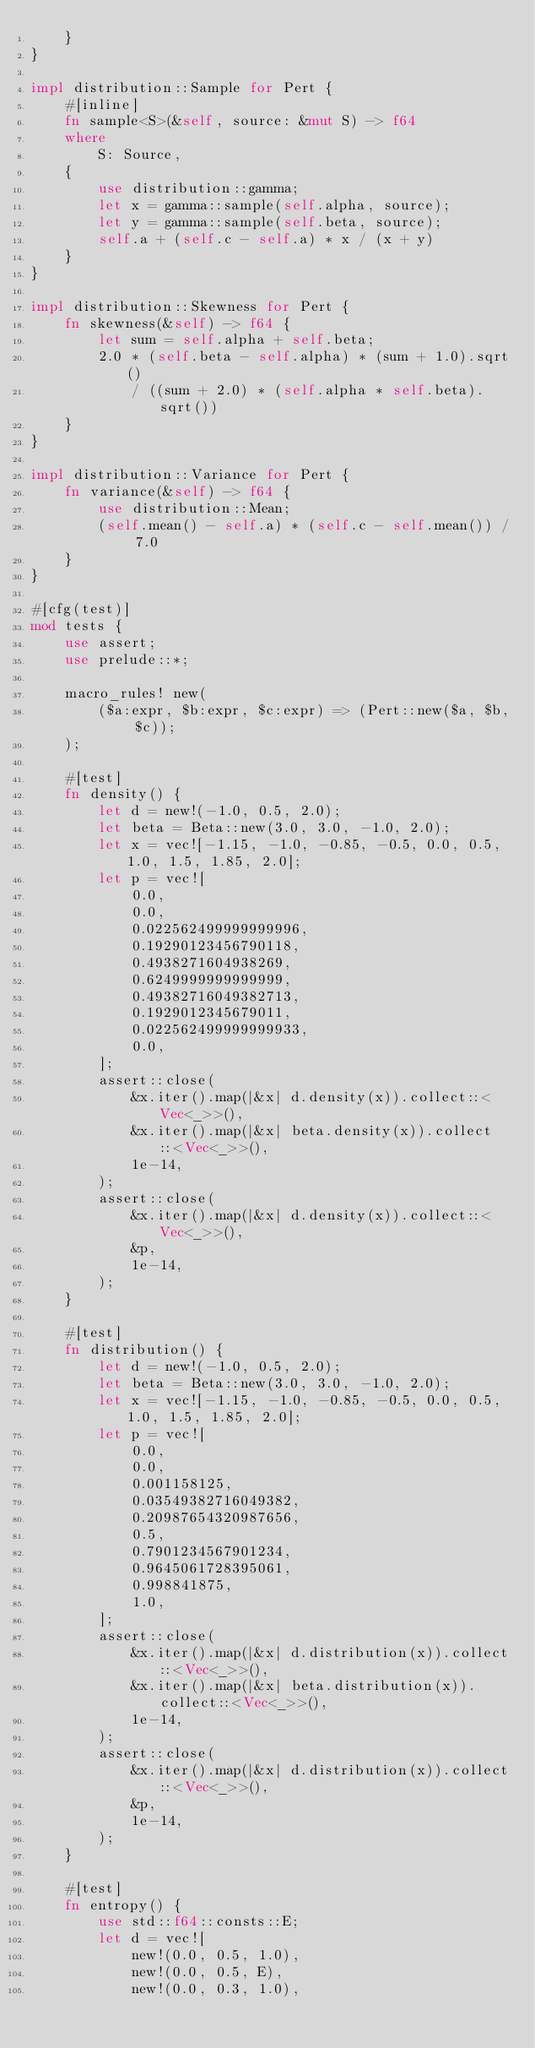Convert code to text. <code><loc_0><loc_0><loc_500><loc_500><_Rust_>    }
}

impl distribution::Sample for Pert {
    #[inline]
    fn sample<S>(&self, source: &mut S) -> f64
    where
        S: Source,
    {
        use distribution::gamma;
        let x = gamma::sample(self.alpha, source);
        let y = gamma::sample(self.beta, source);
        self.a + (self.c - self.a) * x / (x + y)
    }
}

impl distribution::Skewness for Pert {
    fn skewness(&self) -> f64 {
        let sum = self.alpha + self.beta;
        2.0 * (self.beta - self.alpha) * (sum + 1.0).sqrt()
            / ((sum + 2.0) * (self.alpha * self.beta).sqrt())
    }
}

impl distribution::Variance for Pert {
    fn variance(&self) -> f64 {
        use distribution::Mean;
        (self.mean() - self.a) * (self.c - self.mean()) / 7.0
    }
}

#[cfg(test)]
mod tests {
    use assert;
    use prelude::*;

    macro_rules! new(
        ($a:expr, $b:expr, $c:expr) => (Pert::new($a, $b, $c));
    );

    #[test]
    fn density() {
        let d = new!(-1.0, 0.5, 2.0);
        let beta = Beta::new(3.0, 3.0, -1.0, 2.0);
        let x = vec![-1.15, -1.0, -0.85, -0.5, 0.0, 0.5, 1.0, 1.5, 1.85, 2.0];
        let p = vec![
            0.0,
            0.0,
            0.022562499999999996,
            0.19290123456790118,
            0.4938271604938269,
            0.6249999999999999,
            0.49382716049382713,
            0.1929012345679011,
            0.022562499999999933,
            0.0,
        ];
        assert::close(
            &x.iter().map(|&x| d.density(x)).collect::<Vec<_>>(),
            &x.iter().map(|&x| beta.density(x)).collect::<Vec<_>>(),
            1e-14,
        );
        assert::close(
            &x.iter().map(|&x| d.density(x)).collect::<Vec<_>>(),
            &p,
            1e-14,
        );
    }

    #[test]
    fn distribution() {
        let d = new!(-1.0, 0.5, 2.0);
        let beta = Beta::new(3.0, 3.0, -1.0, 2.0);
        let x = vec![-1.15, -1.0, -0.85, -0.5, 0.0, 0.5, 1.0, 1.5, 1.85, 2.0];
        let p = vec![
            0.0,
            0.0,
            0.001158125,
            0.03549382716049382,
            0.20987654320987656,
            0.5,
            0.7901234567901234,
            0.9645061728395061,
            0.998841875,
            1.0,
        ];
        assert::close(
            &x.iter().map(|&x| d.distribution(x)).collect::<Vec<_>>(),
            &x.iter().map(|&x| beta.distribution(x)).collect::<Vec<_>>(),
            1e-14,
        );
        assert::close(
            &x.iter().map(|&x| d.distribution(x)).collect::<Vec<_>>(),
            &p,
            1e-14,
        );
    }

    #[test]
    fn entropy() {
        use std::f64::consts::E;
        let d = vec![
            new!(0.0, 0.5, 1.0),
            new!(0.0, 0.5, E),
            new!(0.0, 0.3, 1.0),</code> 